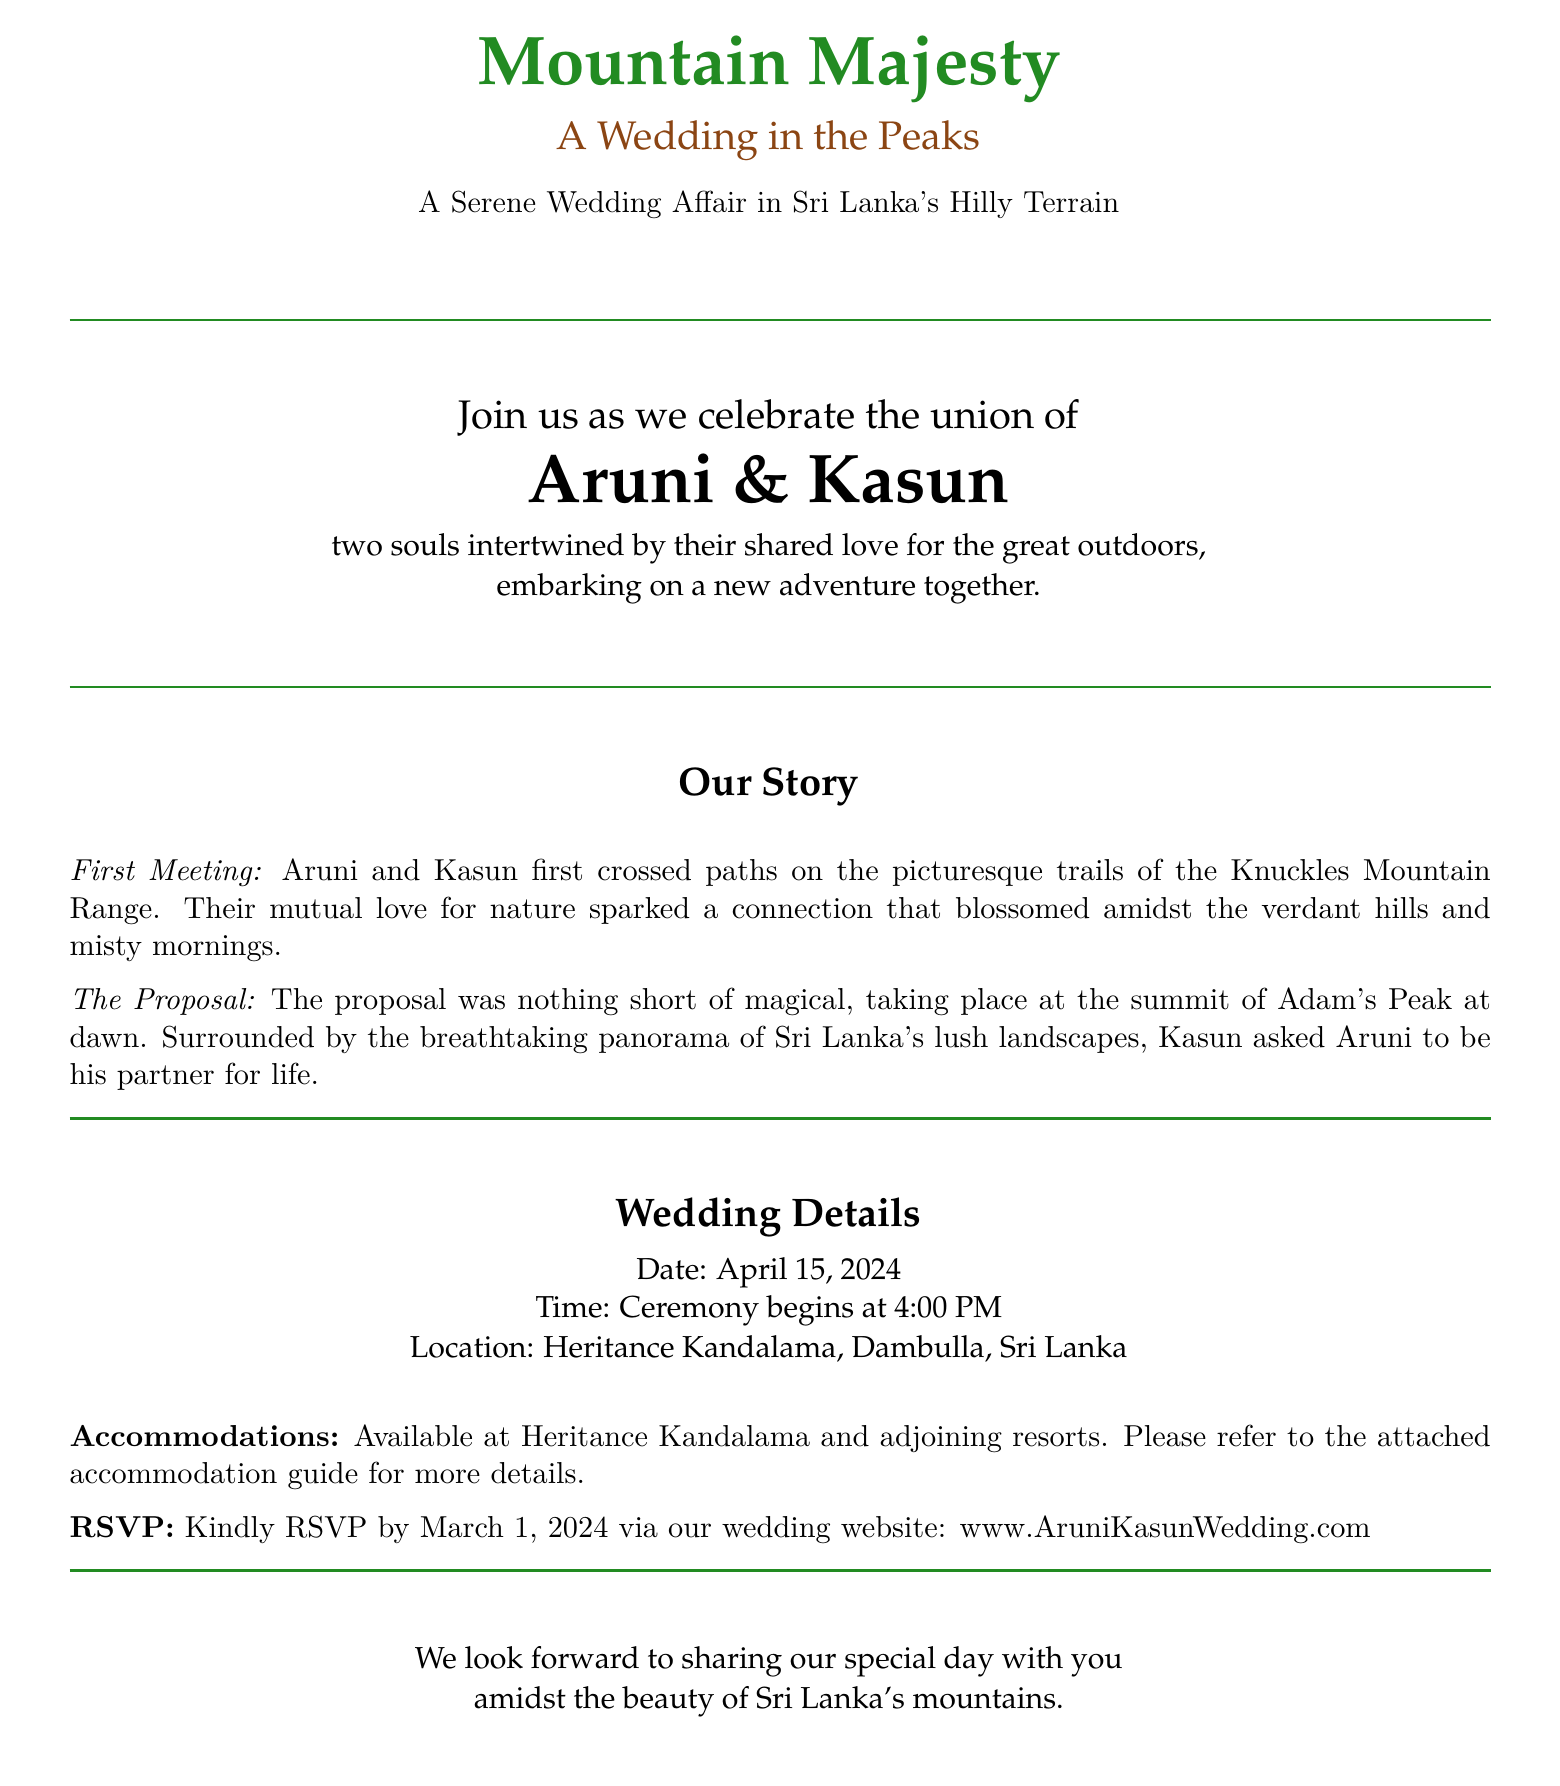What is the date of the wedding? The date of the wedding is specified in the document under the Wedding Details section.
Answer: April 15, 2024 Who are the couple getting married? The couple's names are highlighted prominently in the invitation.
Answer: Aruni & Kasun What is the location of the wedding? The location is provided in the Wedding Details section of the document.
Answer: Heritance Kandalama, Dambulla, Sri Lanka What is the RSVP deadline? The RSVP deadline is indicated in the document with a specific date.
Answer: March 1, 2024 Where did Aruni and Kasun first meet? Their first meeting location is described in the Our Story section.
Answer: Knuckles Mountain Range What was the venue of the proposal? The proposal venue is mentioned as part of their story.
Answer: Adam's Peak What time does the ceremony begin? The ceremony time is detailed in the Wedding Details section.
Answer: 4:00 PM What theme is highlighted in the wedding invitation? The theme is stated in the title and is woven throughout the document's design.
Answer: Mountain Majesty 